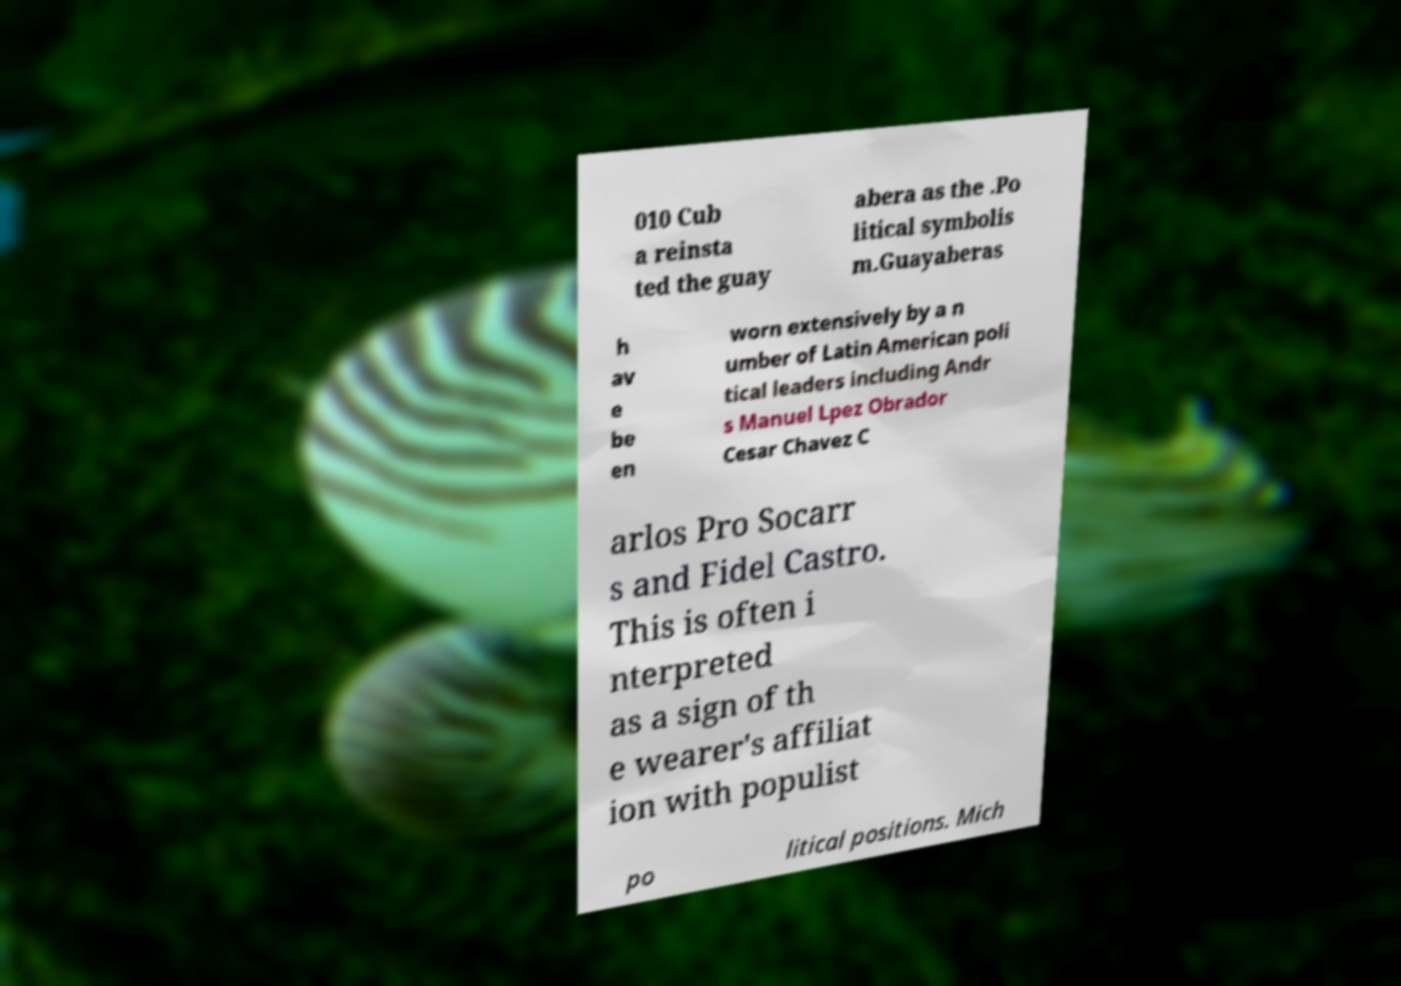For documentation purposes, I need the text within this image transcribed. Could you provide that? 010 Cub a reinsta ted the guay abera as the .Po litical symbolis m.Guayaberas h av e be en worn extensively by a n umber of Latin American poli tical leaders including Andr s Manuel Lpez Obrador Cesar Chavez C arlos Pro Socarr s and Fidel Castro. This is often i nterpreted as a sign of th e wearer's affiliat ion with populist po litical positions. Mich 